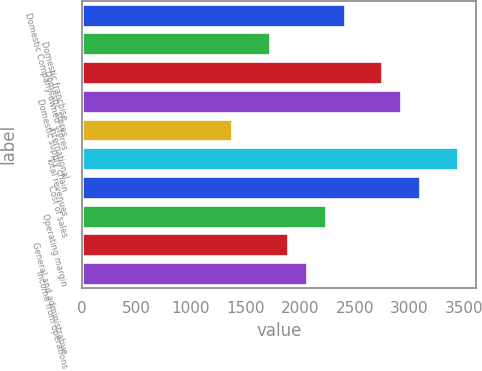Convert chart. <chart><loc_0><loc_0><loc_500><loc_500><bar_chart><fcel>Domestic Company-owned stores<fcel>Domestic franchise<fcel>Domestic stores<fcel>Domestic supply chain<fcel>International<fcel>Total revenues<fcel>Cost of sales<fcel>Operating margin<fcel>General and administrative<fcel>Income from operations<nl><fcel>2407.89<fcel>1720.09<fcel>2751.79<fcel>2923.74<fcel>1376.19<fcel>3439.59<fcel>3095.69<fcel>2235.94<fcel>1892.04<fcel>2063.99<nl></chart> 